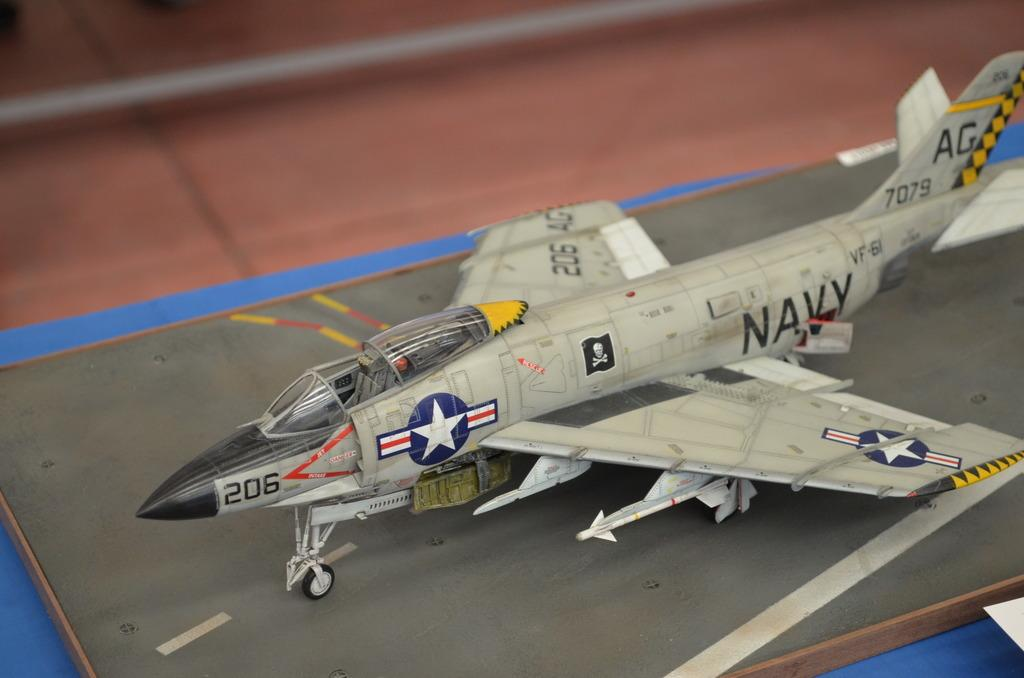<image>
Relay a brief, clear account of the picture shown. A model plane has the Navy logo on the side and the number 206 on the front. 